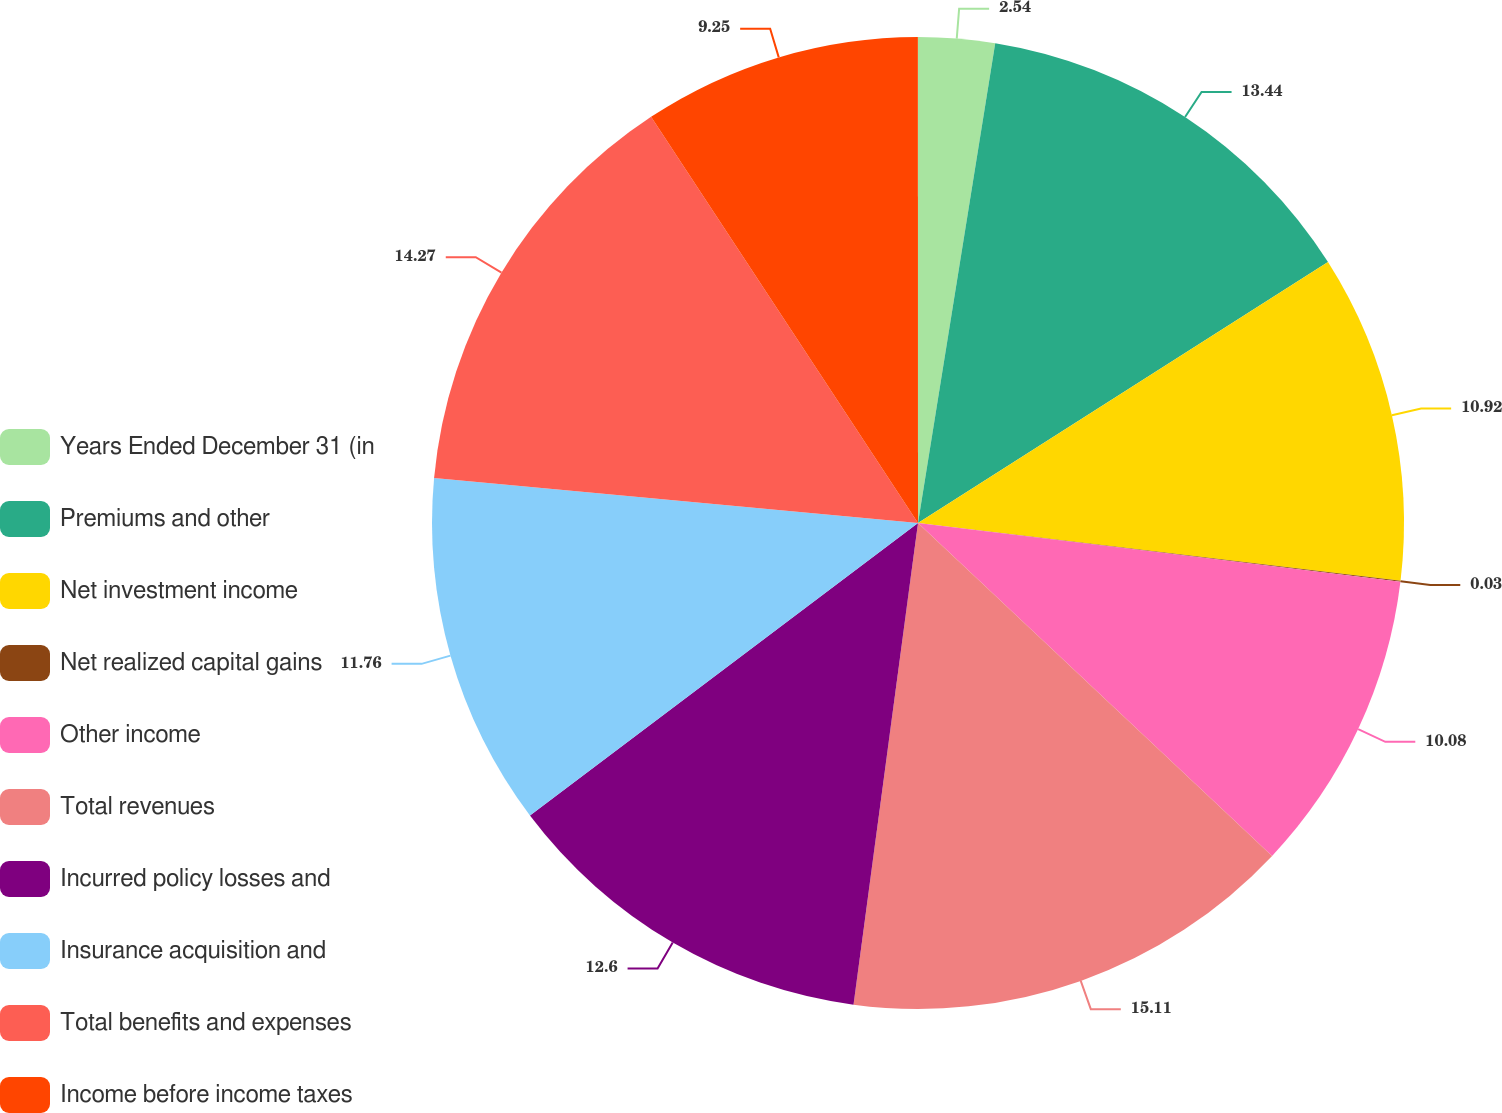Convert chart to OTSL. <chart><loc_0><loc_0><loc_500><loc_500><pie_chart><fcel>Years Ended December 31 (in<fcel>Premiums and other<fcel>Net investment income<fcel>Net realized capital gains<fcel>Other income<fcel>Total revenues<fcel>Incurred policy losses and<fcel>Insurance acquisition and<fcel>Total benefits and expenses<fcel>Income before income taxes<nl><fcel>2.54%<fcel>13.44%<fcel>10.92%<fcel>0.03%<fcel>10.08%<fcel>15.11%<fcel>12.6%<fcel>11.76%<fcel>14.27%<fcel>9.25%<nl></chart> 